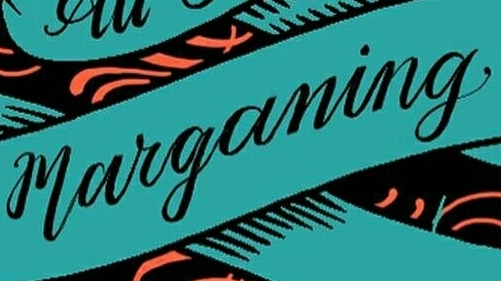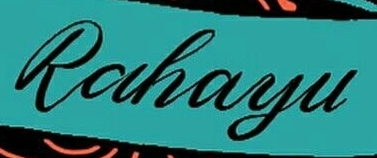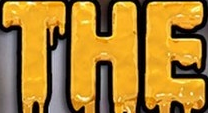Transcribe the words shown in these images in order, separated by a semicolon. marganing; Rahayu; THE 